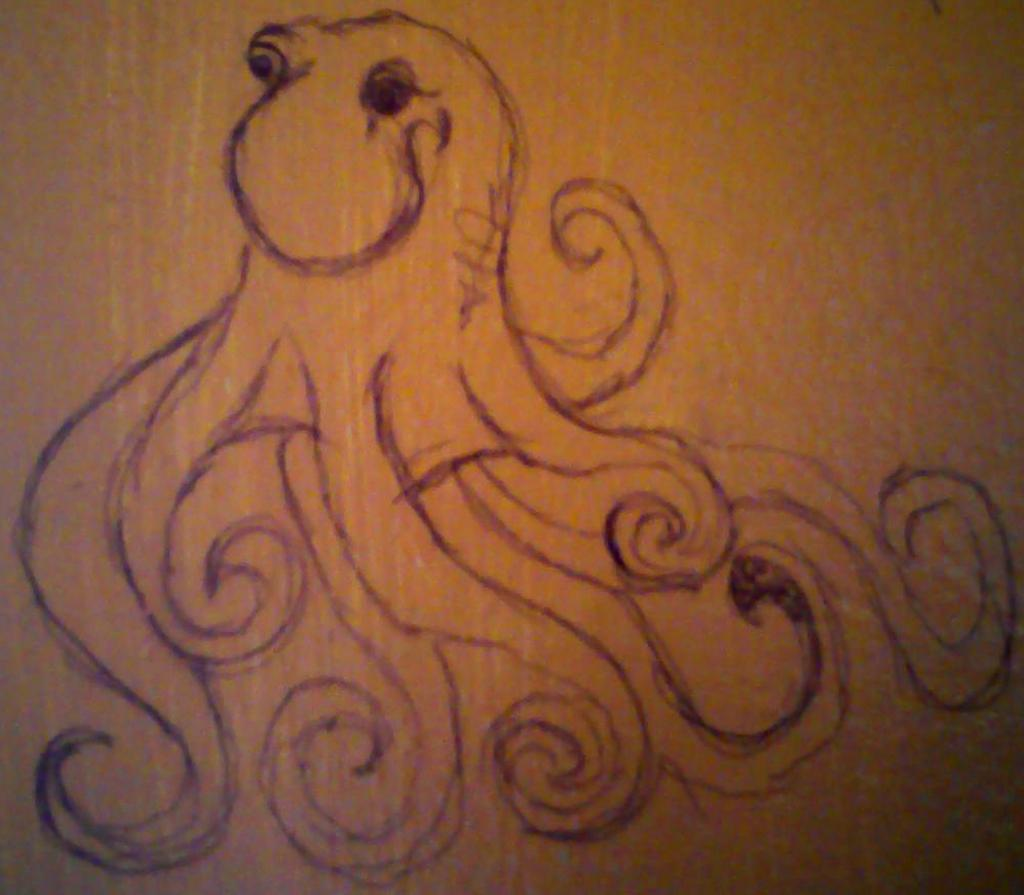What is the color of the surface in the image? The surface in the image is brown in color. What can be seen on the surface? There is a sketch of an octopus on the surface. What is the position of the thumb in the image? There is no thumb present in the image; it only features a sketch of an octopus on a brown surface. 